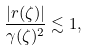<formula> <loc_0><loc_0><loc_500><loc_500>\frac { | r ( \zeta ) | } { \gamma ( \zeta ) ^ { 2 } } \lesssim 1 ,</formula> 